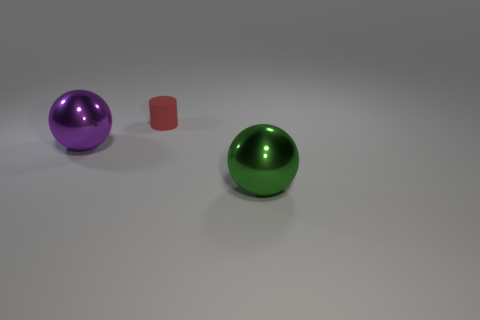Add 2 tiny metal balls. How many objects exist? 5 Subtract all cylinders. How many objects are left? 2 Add 2 metal objects. How many metal objects are left? 4 Add 2 big green spheres. How many big green spheres exist? 3 Subtract 0 brown cylinders. How many objects are left? 3 Subtract all large purple balls. Subtract all small things. How many objects are left? 1 